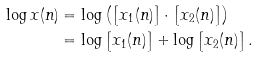<formula> <loc_0><loc_0><loc_500><loc_500>\log x ( n ) & = \log \left ( \left [ x _ { 1 } ( n ) \right ] \cdot \left [ x _ { 2 } ( n ) \right ] \right ) \\ & = \log \left [ x _ { 1 } ( n ) \right ] + \log \left [ x _ { 2 } ( n ) \right ] .</formula> 